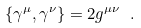<formula> <loc_0><loc_0><loc_500><loc_500>\{ \gamma ^ { \mu } , \gamma ^ { \nu } \} = 2 g ^ { \mu \nu } \ .</formula> 